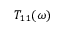<formula> <loc_0><loc_0><loc_500><loc_500>T _ { 1 1 } ( \omega )</formula> 